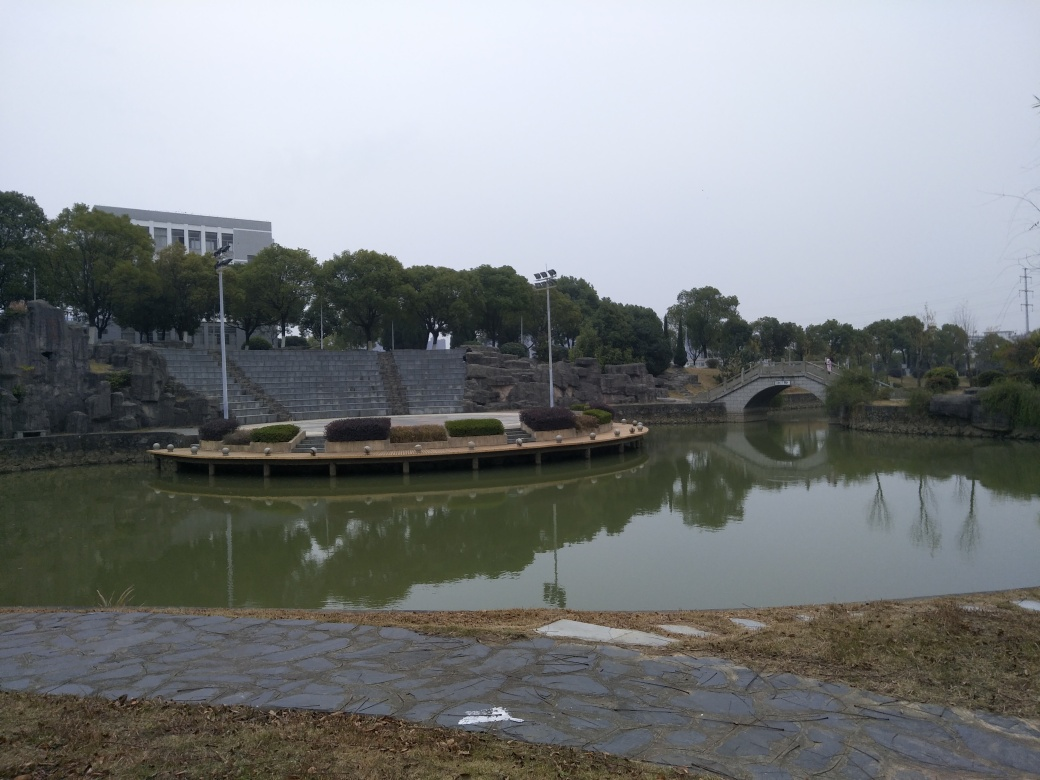Does this setting look like it's used for public or private gatherings? The presence of ample seating around the pond platform and the open space of the amphitheater-style stairs suggest this area is designed for public gatherings and communal activities. The calm water and bridge also create an inviting atmosphere for leisure and social events. 